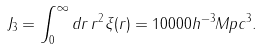<formula> <loc_0><loc_0><loc_500><loc_500>J _ { 3 } = \int _ { 0 } ^ { \infty } d r \, r ^ { 2 } \xi ( r ) = 1 0 0 0 0 h ^ { - 3 } M p c ^ { 3 } .</formula> 